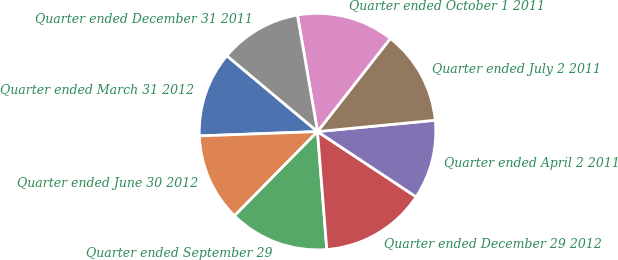<chart> <loc_0><loc_0><loc_500><loc_500><pie_chart><fcel>Quarter ended March 31 2012<fcel>Quarter ended June 30 2012<fcel>Quarter ended September 29<fcel>Quarter ended December 29 2012<fcel>Quarter ended April 2 2011<fcel>Quarter ended July 2 2011<fcel>Quarter ended October 1 2011<fcel>Quarter ended December 31 2011<nl><fcel>11.67%<fcel>12.03%<fcel>13.64%<fcel>14.45%<fcel>10.83%<fcel>12.91%<fcel>13.28%<fcel>11.19%<nl></chart> 